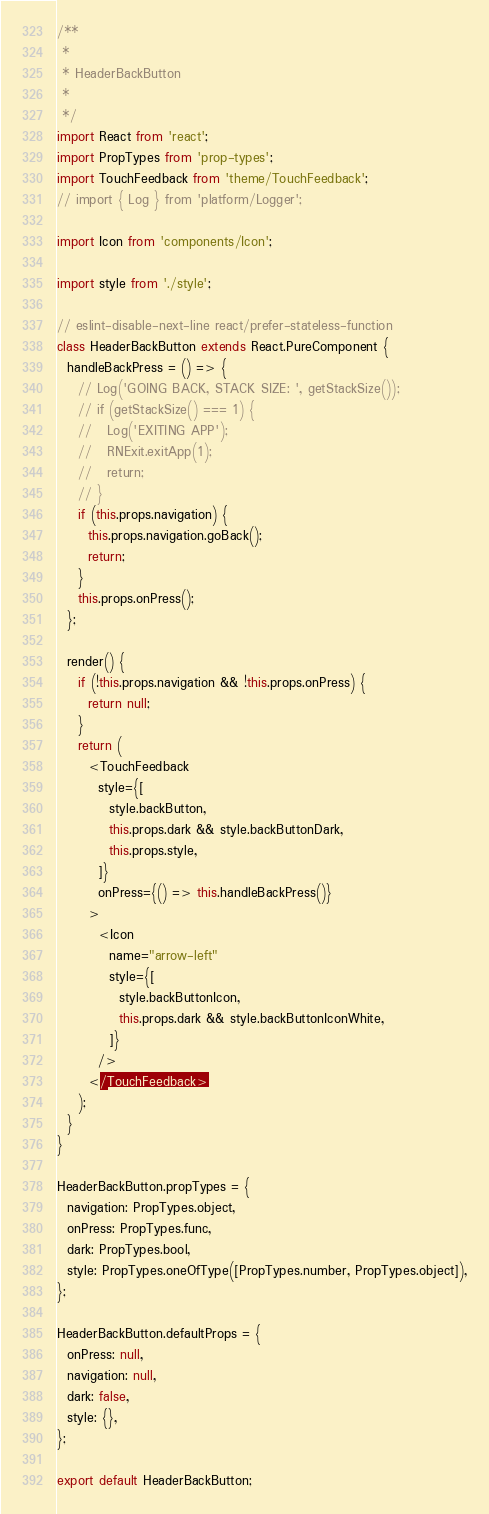Convert code to text. <code><loc_0><loc_0><loc_500><loc_500><_JavaScript_>/**
 *
 * HeaderBackButton
 *
 */
import React from 'react';
import PropTypes from 'prop-types';
import TouchFeedback from 'theme/TouchFeedback';
// import { Log } from 'platform/Logger';

import Icon from 'components/Icon';

import style from './style';

// eslint-disable-next-line react/prefer-stateless-function
class HeaderBackButton extends React.PureComponent {
  handleBackPress = () => {
    // Log('GOING BACK, STACK SIZE: ', getStackSize());
    // if (getStackSize() === 1) {
    //   Log('EXITING APP');
    //   RNExit.exitApp(1);
    //   return;
    // }
    if (this.props.navigation) {
      this.props.navigation.goBack();
      return;
    }
    this.props.onPress();
  };

  render() {
    if (!this.props.navigation && !this.props.onPress) {
      return null;
    }
    return (
      <TouchFeedback
        style={[
          style.backButton,
          this.props.dark && style.backButtonDark,
          this.props.style,
        ]}
        onPress={() => this.handleBackPress()}
      >
        <Icon
          name="arrow-left"
          style={[
            style.backButtonIcon,
            this.props.dark && style.backButtonIconWhite,
          ]}
        />
      </TouchFeedback>
    );
  }
}

HeaderBackButton.propTypes = {
  navigation: PropTypes.object,
  onPress: PropTypes.func,
  dark: PropTypes.bool,
  style: PropTypes.oneOfType([PropTypes.number, PropTypes.object]),
};

HeaderBackButton.defaultProps = {
  onPress: null,
  navigation: null,
  dark: false,
  style: {},
};

export default HeaderBackButton;
</code> 